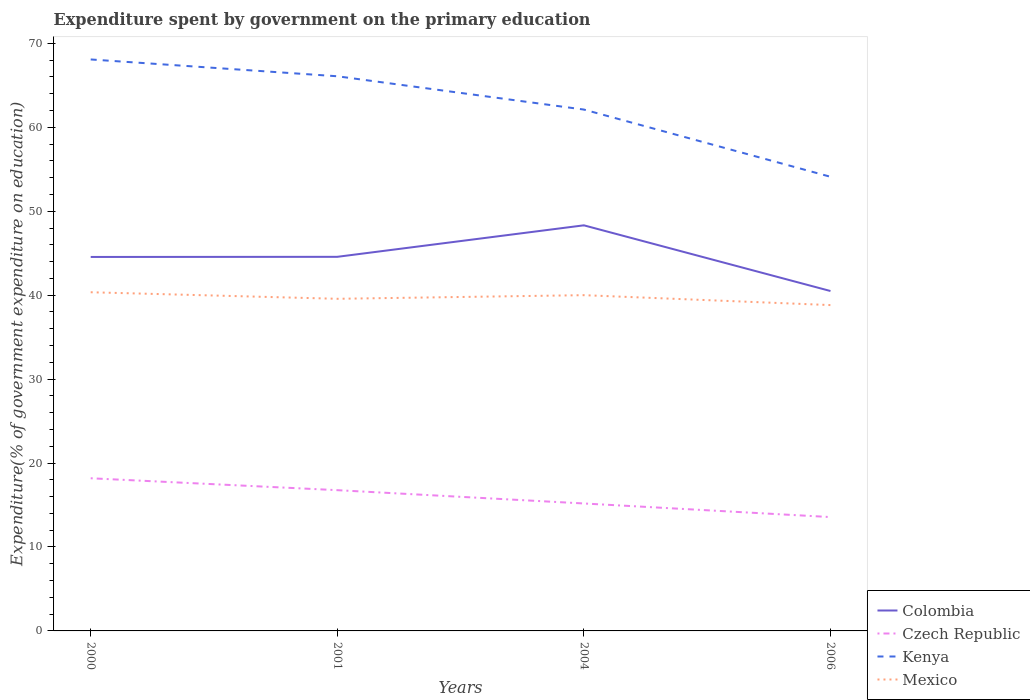Is the number of lines equal to the number of legend labels?
Give a very brief answer. Yes. Across all years, what is the maximum expenditure spent by government on the primary education in Mexico?
Make the answer very short. 38.82. What is the total expenditure spent by government on the primary education in Czech Republic in the graph?
Offer a very short reply. 3.21. What is the difference between the highest and the second highest expenditure spent by government on the primary education in Mexico?
Your answer should be compact. 1.53. Is the expenditure spent by government on the primary education in Colombia strictly greater than the expenditure spent by government on the primary education in Kenya over the years?
Your answer should be very brief. Yes. How many lines are there?
Offer a terse response. 4. How many years are there in the graph?
Give a very brief answer. 4. Are the values on the major ticks of Y-axis written in scientific E-notation?
Provide a short and direct response. No. Does the graph contain grids?
Provide a short and direct response. No. How many legend labels are there?
Provide a succinct answer. 4. How are the legend labels stacked?
Offer a terse response. Vertical. What is the title of the graph?
Offer a very short reply. Expenditure spent by government on the primary education. Does "Papua New Guinea" appear as one of the legend labels in the graph?
Provide a short and direct response. No. What is the label or title of the X-axis?
Make the answer very short. Years. What is the label or title of the Y-axis?
Offer a very short reply. Expenditure(% of government expenditure on education). What is the Expenditure(% of government expenditure on education) of Colombia in 2000?
Give a very brief answer. 44.56. What is the Expenditure(% of government expenditure on education) of Czech Republic in 2000?
Give a very brief answer. 18.19. What is the Expenditure(% of government expenditure on education) of Kenya in 2000?
Ensure brevity in your answer.  68.09. What is the Expenditure(% of government expenditure on education) of Mexico in 2000?
Give a very brief answer. 40.35. What is the Expenditure(% of government expenditure on education) in Colombia in 2001?
Provide a succinct answer. 44.57. What is the Expenditure(% of government expenditure on education) in Czech Republic in 2001?
Ensure brevity in your answer.  16.77. What is the Expenditure(% of government expenditure on education) of Kenya in 2001?
Your answer should be very brief. 66.08. What is the Expenditure(% of government expenditure on education) in Mexico in 2001?
Keep it short and to the point. 39.57. What is the Expenditure(% of government expenditure on education) in Colombia in 2004?
Keep it short and to the point. 48.32. What is the Expenditure(% of government expenditure on education) in Czech Republic in 2004?
Provide a succinct answer. 15.18. What is the Expenditure(% of government expenditure on education) in Kenya in 2004?
Give a very brief answer. 62.12. What is the Expenditure(% of government expenditure on education) of Mexico in 2004?
Your response must be concise. 40. What is the Expenditure(% of government expenditure on education) of Colombia in 2006?
Ensure brevity in your answer.  40.5. What is the Expenditure(% of government expenditure on education) in Czech Republic in 2006?
Your answer should be very brief. 13.56. What is the Expenditure(% of government expenditure on education) of Kenya in 2006?
Your answer should be very brief. 54.11. What is the Expenditure(% of government expenditure on education) in Mexico in 2006?
Keep it short and to the point. 38.82. Across all years, what is the maximum Expenditure(% of government expenditure on education) in Colombia?
Provide a short and direct response. 48.32. Across all years, what is the maximum Expenditure(% of government expenditure on education) in Czech Republic?
Your answer should be very brief. 18.19. Across all years, what is the maximum Expenditure(% of government expenditure on education) in Kenya?
Ensure brevity in your answer.  68.09. Across all years, what is the maximum Expenditure(% of government expenditure on education) in Mexico?
Offer a very short reply. 40.35. Across all years, what is the minimum Expenditure(% of government expenditure on education) in Colombia?
Keep it short and to the point. 40.5. Across all years, what is the minimum Expenditure(% of government expenditure on education) of Czech Republic?
Offer a terse response. 13.56. Across all years, what is the minimum Expenditure(% of government expenditure on education) of Kenya?
Offer a very short reply. 54.11. Across all years, what is the minimum Expenditure(% of government expenditure on education) in Mexico?
Your answer should be very brief. 38.82. What is the total Expenditure(% of government expenditure on education) in Colombia in the graph?
Give a very brief answer. 177.95. What is the total Expenditure(% of government expenditure on education) of Czech Republic in the graph?
Offer a terse response. 63.71. What is the total Expenditure(% of government expenditure on education) of Kenya in the graph?
Your answer should be very brief. 250.4. What is the total Expenditure(% of government expenditure on education) of Mexico in the graph?
Keep it short and to the point. 158.75. What is the difference between the Expenditure(% of government expenditure on education) in Colombia in 2000 and that in 2001?
Your answer should be very brief. -0.01. What is the difference between the Expenditure(% of government expenditure on education) of Czech Republic in 2000 and that in 2001?
Make the answer very short. 1.42. What is the difference between the Expenditure(% of government expenditure on education) of Kenya in 2000 and that in 2001?
Your response must be concise. 2. What is the difference between the Expenditure(% of government expenditure on education) in Mexico in 2000 and that in 2001?
Keep it short and to the point. 0.78. What is the difference between the Expenditure(% of government expenditure on education) in Colombia in 2000 and that in 2004?
Offer a very short reply. -3.77. What is the difference between the Expenditure(% of government expenditure on education) of Czech Republic in 2000 and that in 2004?
Make the answer very short. 3. What is the difference between the Expenditure(% of government expenditure on education) of Kenya in 2000 and that in 2004?
Your response must be concise. 5.97. What is the difference between the Expenditure(% of government expenditure on education) of Mexico in 2000 and that in 2004?
Make the answer very short. 0.35. What is the difference between the Expenditure(% of government expenditure on education) of Colombia in 2000 and that in 2006?
Offer a terse response. 4.06. What is the difference between the Expenditure(% of government expenditure on education) of Czech Republic in 2000 and that in 2006?
Your response must be concise. 4.62. What is the difference between the Expenditure(% of government expenditure on education) of Kenya in 2000 and that in 2006?
Give a very brief answer. 13.98. What is the difference between the Expenditure(% of government expenditure on education) in Mexico in 2000 and that in 2006?
Offer a terse response. 1.53. What is the difference between the Expenditure(% of government expenditure on education) of Colombia in 2001 and that in 2004?
Your response must be concise. -3.75. What is the difference between the Expenditure(% of government expenditure on education) in Czech Republic in 2001 and that in 2004?
Your answer should be very brief. 1.58. What is the difference between the Expenditure(% of government expenditure on education) in Kenya in 2001 and that in 2004?
Provide a short and direct response. 3.97. What is the difference between the Expenditure(% of government expenditure on education) of Mexico in 2001 and that in 2004?
Give a very brief answer. -0.43. What is the difference between the Expenditure(% of government expenditure on education) of Colombia in 2001 and that in 2006?
Make the answer very short. 4.07. What is the difference between the Expenditure(% of government expenditure on education) of Czech Republic in 2001 and that in 2006?
Provide a succinct answer. 3.21. What is the difference between the Expenditure(% of government expenditure on education) in Kenya in 2001 and that in 2006?
Keep it short and to the point. 11.98. What is the difference between the Expenditure(% of government expenditure on education) of Mexico in 2001 and that in 2006?
Give a very brief answer. 0.75. What is the difference between the Expenditure(% of government expenditure on education) of Colombia in 2004 and that in 2006?
Ensure brevity in your answer.  7.83. What is the difference between the Expenditure(% of government expenditure on education) of Czech Republic in 2004 and that in 2006?
Give a very brief answer. 1.62. What is the difference between the Expenditure(% of government expenditure on education) in Kenya in 2004 and that in 2006?
Ensure brevity in your answer.  8.01. What is the difference between the Expenditure(% of government expenditure on education) in Mexico in 2004 and that in 2006?
Keep it short and to the point. 1.18. What is the difference between the Expenditure(% of government expenditure on education) in Colombia in 2000 and the Expenditure(% of government expenditure on education) in Czech Republic in 2001?
Keep it short and to the point. 27.79. What is the difference between the Expenditure(% of government expenditure on education) in Colombia in 2000 and the Expenditure(% of government expenditure on education) in Kenya in 2001?
Give a very brief answer. -21.53. What is the difference between the Expenditure(% of government expenditure on education) in Colombia in 2000 and the Expenditure(% of government expenditure on education) in Mexico in 2001?
Provide a succinct answer. 4.99. What is the difference between the Expenditure(% of government expenditure on education) of Czech Republic in 2000 and the Expenditure(% of government expenditure on education) of Kenya in 2001?
Make the answer very short. -47.9. What is the difference between the Expenditure(% of government expenditure on education) in Czech Republic in 2000 and the Expenditure(% of government expenditure on education) in Mexico in 2001?
Provide a short and direct response. -21.38. What is the difference between the Expenditure(% of government expenditure on education) in Kenya in 2000 and the Expenditure(% of government expenditure on education) in Mexico in 2001?
Give a very brief answer. 28.52. What is the difference between the Expenditure(% of government expenditure on education) of Colombia in 2000 and the Expenditure(% of government expenditure on education) of Czech Republic in 2004?
Provide a short and direct response. 29.37. What is the difference between the Expenditure(% of government expenditure on education) in Colombia in 2000 and the Expenditure(% of government expenditure on education) in Kenya in 2004?
Ensure brevity in your answer.  -17.56. What is the difference between the Expenditure(% of government expenditure on education) in Colombia in 2000 and the Expenditure(% of government expenditure on education) in Mexico in 2004?
Your answer should be very brief. 4.55. What is the difference between the Expenditure(% of government expenditure on education) in Czech Republic in 2000 and the Expenditure(% of government expenditure on education) in Kenya in 2004?
Your answer should be compact. -43.93. What is the difference between the Expenditure(% of government expenditure on education) of Czech Republic in 2000 and the Expenditure(% of government expenditure on education) of Mexico in 2004?
Keep it short and to the point. -21.81. What is the difference between the Expenditure(% of government expenditure on education) of Kenya in 2000 and the Expenditure(% of government expenditure on education) of Mexico in 2004?
Ensure brevity in your answer.  28.08. What is the difference between the Expenditure(% of government expenditure on education) in Colombia in 2000 and the Expenditure(% of government expenditure on education) in Czech Republic in 2006?
Ensure brevity in your answer.  30.99. What is the difference between the Expenditure(% of government expenditure on education) in Colombia in 2000 and the Expenditure(% of government expenditure on education) in Kenya in 2006?
Provide a short and direct response. -9.55. What is the difference between the Expenditure(% of government expenditure on education) in Colombia in 2000 and the Expenditure(% of government expenditure on education) in Mexico in 2006?
Keep it short and to the point. 5.74. What is the difference between the Expenditure(% of government expenditure on education) of Czech Republic in 2000 and the Expenditure(% of government expenditure on education) of Kenya in 2006?
Your response must be concise. -35.92. What is the difference between the Expenditure(% of government expenditure on education) in Czech Republic in 2000 and the Expenditure(% of government expenditure on education) in Mexico in 2006?
Provide a short and direct response. -20.63. What is the difference between the Expenditure(% of government expenditure on education) of Kenya in 2000 and the Expenditure(% of government expenditure on education) of Mexico in 2006?
Ensure brevity in your answer.  29.27. What is the difference between the Expenditure(% of government expenditure on education) of Colombia in 2001 and the Expenditure(% of government expenditure on education) of Czech Republic in 2004?
Provide a succinct answer. 29.39. What is the difference between the Expenditure(% of government expenditure on education) of Colombia in 2001 and the Expenditure(% of government expenditure on education) of Kenya in 2004?
Make the answer very short. -17.55. What is the difference between the Expenditure(% of government expenditure on education) in Colombia in 2001 and the Expenditure(% of government expenditure on education) in Mexico in 2004?
Give a very brief answer. 4.57. What is the difference between the Expenditure(% of government expenditure on education) in Czech Republic in 2001 and the Expenditure(% of government expenditure on education) in Kenya in 2004?
Ensure brevity in your answer.  -45.35. What is the difference between the Expenditure(% of government expenditure on education) in Czech Republic in 2001 and the Expenditure(% of government expenditure on education) in Mexico in 2004?
Offer a terse response. -23.23. What is the difference between the Expenditure(% of government expenditure on education) of Kenya in 2001 and the Expenditure(% of government expenditure on education) of Mexico in 2004?
Give a very brief answer. 26.08. What is the difference between the Expenditure(% of government expenditure on education) in Colombia in 2001 and the Expenditure(% of government expenditure on education) in Czech Republic in 2006?
Your response must be concise. 31.01. What is the difference between the Expenditure(% of government expenditure on education) in Colombia in 2001 and the Expenditure(% of government expenditure on education) in Kenya in 2006?
Give a very brief answer. -9.54. What is the difference between the Expenditure(% of government expenditure on education) in Colombia in 2001 and the Expenditure(% of government expenditure on education) in Mexico in 2006?
Your response must be concise. 5.75. What is the difference between the Expenditure(% of government expenditure on education) in Czech Republic in 2001 and the Expenditure(% of government expenditure on education) in Kenya in 2006?
Your response must be concise. -37.34. What is the difference between the Expenditure(% of government expenditure on education) of Czech Republic in 2001 and the Expenditure(% of government expenditure on education) of Mexico in 2006?
Offer a terse response. -22.05. What is the difference between the Expenditure(% of government expenditure on education) in Kenya in 2001 and the Expenditure(% of government expenditure on education) in Mexico in 2006?
Offer a very short reply. 27.26. What is the difference between the Expenditure(% of government expenditure on education) in Colombia in 2004 and the Expenditure(% of government expenditure on education) in Czech Republic in 2006?
Make the answer very short. 34.76. What is the difference between the Expenditure(% of government expenditure on education) of Colombia in 2004 and the Expenditure(% of government expenditure on education) of Kenya in 2006?
Provide a short and direct response. -5.78. What is the difference between the Expenditure(% of government expenditure on education) in Colombia in 2004 and the Expenditure(% of government expenditure on education) in Mexico in 2006?
Your response must be concise. 9.5. What is the difference between the Expenditure(% of government expenditure on education) in Czech Republic in 2004 and the Expenditure(% of government expenditure on education) in Kenya in 2006?
Your answer should be compact. -38.92. What is the difference between the Expenditure(% of government expenditure on education) in Czech Republic in 2004 and the Expenditure(% of government expenditure on education) in Mexico in 2006?
Make the answer very short. -23.64. What is the difference between the Expenditure(% of government expenditure on education) in Kenya in 2004 and the Expenditure(% of government expenditure on education) in Mexico in 2006?
Offer a terse response. 23.3. What is the average Expenditure(% of government expenditure on education) of Colombia per year?
Provide a succinct answer. 44.49. What is the average Expenditure(% of government expenditure on education) in Czech Republic per year?
Provide a succinct answer. 15.93. What is the average Expenditure(% of government expenditure on education) of Kenya per year?
Your answer should be very brief. 62.6. What is the average Expenditure(% of government expenditure on education) of Mexico per year?
Keep it short and to the point. 39.69. In the year 2000, what is the difference between the Expenditure(% of government expenditure on education) of Colombia and Expenditure(% of government expenditure on education) of Czech Republic?
Your answer should be very brief. 26.37. In the year 2000, what is the difference between the Expenditure(% of government expenditure on education) of Colombia and Expenditure(% of government expenditure on education) of Kenya?
Your answer should be very brief. -23.53. In the year 2000, what is the difference between the Expenditure(% of government expenditure on education) in Colombia and Expenditure(% of government expenditure on education) in Mexico?
Give a very brief answer. 4.21. In the year 2000, what is the difference between the Expenditure(% of government expenditure on education) of Czech Republic and Expenditure(% of government expenditure on education) of Kenya?
Offer a very short reply. -49.9. In the year 2000, what is the difference between the Expenditure(% of government expenditure on education) of Czech Republic and Expenditure(% of government expenditure on education) of Mexico?
Your answer should be very brief. -22.16. In the year 2000, what is the difference between the Expenditure(% of government expenditure on education) of Kenya and Expenditure(% of government expenditure on education) of Mexico?
Your answer should be very brief. 27.74. In the year 2001, what is the difference between the Expenditure(% of government expenditure on education) in Colombia and Expenditure(% of government expenditure on education) in Czech Republic?
Provide a short and direct response. 27.8. In the year 2001, what is the difference between the Expenditure(% of government expenditure on education) of Colombia and Expenditure(% of government expenditure on education) of Kenya?
Keep it short and to the point. -21.51. In the year 2001, what is the difference between the Expenditure(% of government expenditure on education) of Colombia and Expenditure(% of government expenditure on education) of Mexico?
Provide a short and direct response. 5. In the year 2001, what is the difference between the Expenditure(% of government expenditure on education) of Czech Republic and Expenditure(% of government expenditure on education) of Kenya?
Keep it short and to the point. -49.31. In the year 2001, what is the difference between the Expenditure(% of government expenditure on education) of Czech Republic and Expenditure(% of government expenditure on education) of Mexico?
Your answer should be very brief. -22.8. In the year 2001, what is the difference between the Expenditure(% of government expenditure on education) in Kenya and Expenditure(% of government expenditure on education) in Mexico?
Provide a short and direct response. 26.51. In the year 2004, what is the difference between the Expenditure(% of government expenditure on education) in Colombia and Expenditure(% of government expenditure on education) in Czech Republic?
Ensure brevity in your answer.  33.14. In the year 2004, what is the difference between the Expenditure(% of government expenditure on education) in Colombia and Expenditure(% of government expenditure on education) in Kenya?
Make the answer very short. -13.79. In the year 2004, what is the difference between the Expenditure(% of government expenditure on education) of Colombia and Expenditure(% of government expenditure on education) of Mexico?
Provide a short and direct response. 8.32. In the year 2004, what is the difference between the Expenditure(% of government expenditure on education) in Czech Republic and Expenditure(% of government expenditure on education) in Kenya?
Give a very brief answer. -46.93. In the year 2004, what is the difference between the Expenditure(% of government expenditure on education) of Czech Republic and Expenditure(% of government expenditure on education) of Mexico?
Your response must be concise. -24.82. In the year 2004, what is the difference between the Expenditure(% of government expenditure on education) in Kenya and Expenditure(% of government expenditure on education) in Mexico?
Give a very brief answer. 22.11. In the year 2006, what is the difference between the Expenditure(% of government expenditure on education) in Colombia and Expenditure(% of government expenditure on education) in Czech Republic?
Your answer should be very brief. 26.93. In the year 2006, what is the difference between the Expenditure(% of government expenditure on education) of Colombia and Expenditure(% of government expenditure on education) of Kenya?
Ensure brevity in your answer.  -13.61. In the year 2006, what is the difference between the Expenditure(% of government expenditure on education) of Colombia and Expenditure(% of government expenditure on education) of Mexico?
Keep it short and to the point. 1.68. In the year 2006, what is the difference between the Expenditure(% of government expenditure on education) of Czech Republic and Expenditure(% of government expenditure on education) of Kenya?
Give a very brief answer. -40.54. In the year 2006, what is the difference between the Expenditure(% of government expenditure on education) of Czech Republic and Expenditure(% of government expenditure on education) of Mexico?
Your answer should be compact. -25.26. In the year 2006, what is the difference between the Expenditure(% of government expenditure on education) in Kenya and Expenditure(% of government expenditure on education) in Mexico?
Provide a short and direct response. 15.29. What is the ratio of the Expenditure(% of government expenditure on education) of Czech Republic in 2000 to that in 2001?
Your response must be concise. 1.08. What is the ratio of the Expenditure(% of government expenditure on education) in Kenya in 2000 to that in 2001?
Offer a terse response. 1.03. What is the ratio of the Expenditure(% of government expenditure on education) in Mexico in 2000 to that in 2001?
Provide a short and direct response. 1.02. What is the ratio of the Expenditure(% of government expenditure on education) in Colombia in 2000 to that in 2004?
Offer a terse response. 0.92. What is the ratio of the Expenditure(% of government expenditure on education) in Czech Republic in 2000 to that in 2004?
Give a very brief answer. 1.2. What is the ratio of the Expenditure(% of government expenditure on education) in Kenya in 2000 to that in 2004?
Give a very brief answer. 1.1. What is the ratio of the Expenditure(% of government expenditure on education) of Mexico in 2000 to that in 2004?
Provide a succinct answer. 1.01. What is the ratio of the Expenditure(% of government expenditure on education) of Colombia in 2000 to that in 2006?
Make the answer very short. 1.1. What is the ratio of the Expenditure(% of government expenditure on education) of Czech Republic in 2000 to that in 2006?
Make the answer very short. 1.34. What is the ratio of the Expenditure(% of government expenditure on education) of Kenya in 2000 to that in 2006?
Make the answer very short. 1.26. What is the ratio of the Expenditure(% of government expenditure on education) of Mexico in 2000 to that in 2006?
Make the answer very short. 1.04. What is the ratio of the Expenditure(% of government expenditure on education) of Colombia in 2001 to that in 2004?
Your response must be concise. 0.92. What is the ratio of the Expenditure(% of government expenditure on education) in Czech Republic in 2001 to that in 2004?
Offer a very short reply. 1.1. What is the ratio of the Expenditure(% of government expenditure on education) in Kenya in 2001 to that in 2004?
Make the answer very short. 1.06. What is the ratio of the Expenditure(% of government expenditure on education) in Mexico in 2001 to that in 2004?
Give a very brief answer. 0.99. What is the ratio of the Expenditure(% of government expenditure on education) of Colombia in 2001 to that in 2006?
Keep it short and to the point. 1.1. What is the ratio of the Expenditure(% of government expenditure on education) of Czech Republic in 2001 to that in 2006?
Provide a succinct answer. 1.24. What is the ratio of the Expenditure(% of government expenditure on education) in Kenya in 2001 to that in 2006?
Give a very brief answer. 1.22. What is the ratio of the Expenditure(% of government expenditure on education) in Mexico in 2001 to that in 2006?
Give a very brief answer. 1.02. What is the ratio of the Expenditure(% of government expenditure on education) of Colombia in 2004 to that in 2006?
Offer a very short reply. 1.19. What is the ratio of the Expenditure(% of government expenditure on education) of Czech Republic in 2004 to that in 2006?
Provide a succinct answer. 1.12. What is the ratio of the Expenditure(% of government expenditure on education) of Kenya in 2004 to that in 2006?
Your answer should be compact. 1.15. What is the ratio of the Expenditure(% of government expenditure on education) in Mexico in 2004 to that in 2006?
Provide a short and direct response. 1.03. What is the difference between the highest and the second highest Expenditure(% of government expenditure on education) of Colombia?
Make the answer very short. 3.75. What is the difference between the highest and the second highest Expenditure(% of government expenditure on education) of Czech Republic?
Keep it short and to the point. 1.42. What is the difference between the highest and the second highest Expenditure(% of government expenditure on education) of Kenya?
Make the answer very short. 2. What is the difference between the highest and the second highest Expenditure(% of government expenditure on education) in Mexico?
Ensure brevity in your answer.  0.35. What is the difference between the highest and the lowest Expenditure(% of government expenditure on education) in Colombia?
Your response must be concise. 7.83. What is the difference between the highest and the lowest Expenditure(% of government expenditure on education) of Czech Republic?
Your answer should be very brief. 4.62. What is the difference between the highest and the lowest Expenditure(% of government expenditure on education) in Kenya?
Your answer should be very brief. 13.98. What is the difference between the highest and the lowest Expenditure(% of government expenditure on education) in Mexico?
Ensure brevity in your answer.  1.53. 